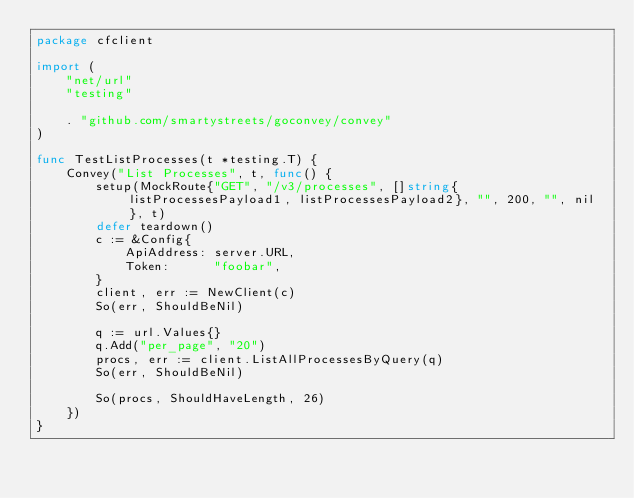Convert code to text. <code><loc_0><loc_0><loc_500><loc_500><_Go_>package cfclient

import (
	"net/url"
	"testing"

	. "github.com/smartystreets/goconvey/convey"
)

func TestListProcesses(t *testing.T) {
	Convey("List Processes", t, func() {
		setup(MockRoute{"GET", "/v3/processes", []string{listProcessesPayload1, listProcessesPayload2}, "", 200, "", nil}, t)
		defer teardown()
		c := &Config{
			ApiAddress: server.URL,
			Token:      "foobar",
		}
		client, err := NewClient(c)
		So(err, ShouldBeNil)

		q := url.Values{}
		q.Add("per_page", "20")
		procs, err := client.ListAllProcessesByQuery(q)
		So(err, ShouldBeNil)

		So(procs, ShouldHaveLength, 26)
	})
}
</code> 